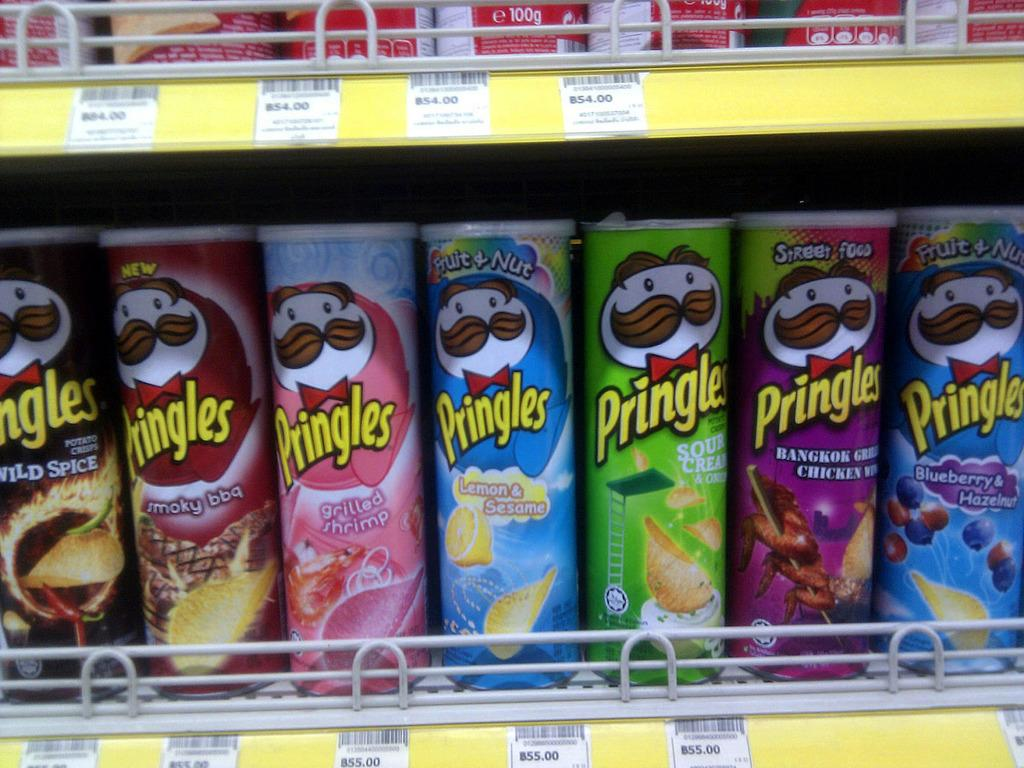What objects are present in the image? There are bottles in the image. How are the bottles arranged or organized? The bottles are on racks. What type of bridge can be seen in the image? There is no bridge present in the image; it only features bottles on racks. 